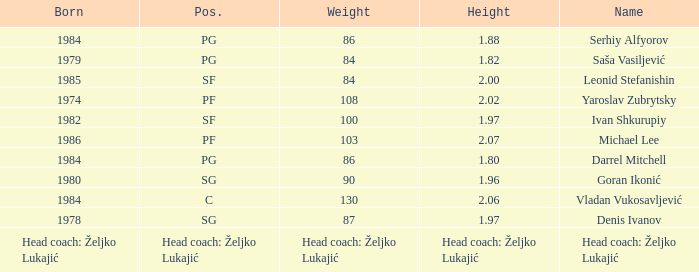What was the weight of Serhiy Alfyorov? 86.0. 